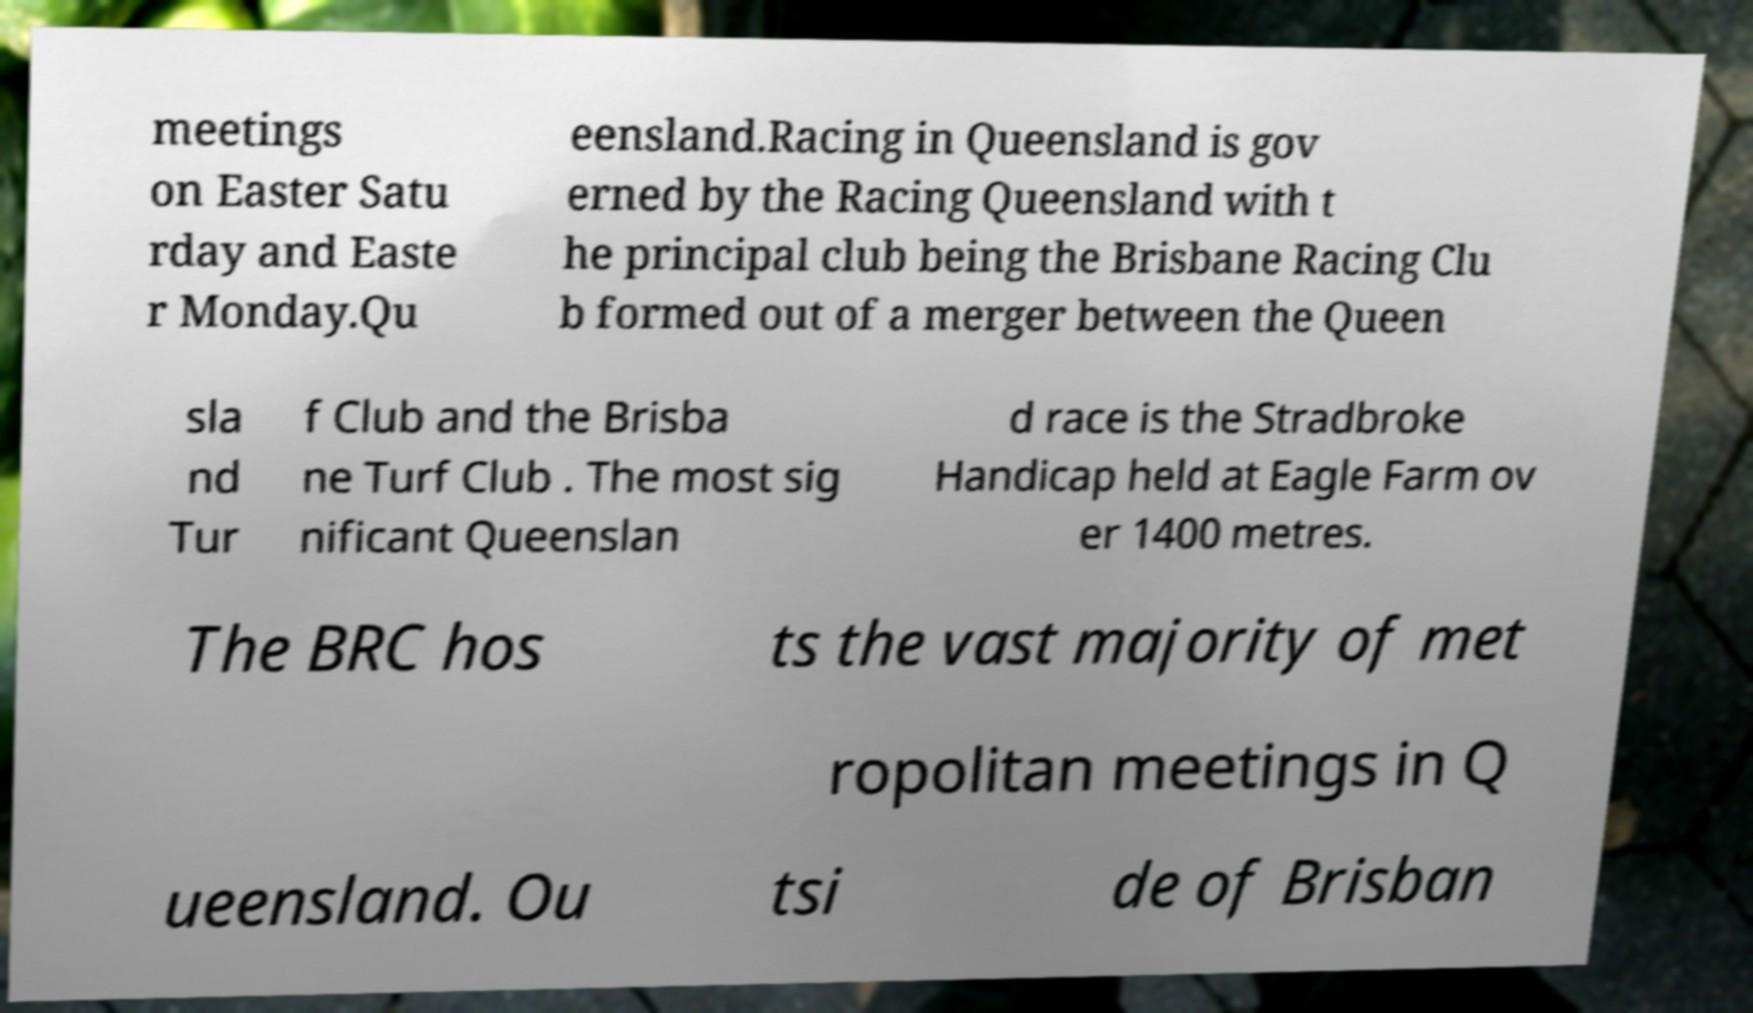Could you extract and type out the text from this image? meetings on Easter Satu rday and Easte r Monday.Qu eensland.Racing in Queensland is gov erned by the Racing Queensland with t he principal club being the Brisbane Racing Clu b formed out of a merger between the Queen sla nd Tur f Club and the Brisba ne Turf Club . The most sig nificant Queenslan d race is the Stradbroke Handicap held at Eagle Farm ov er 1400 metres. The BRC hos ts the vast majority of met ropolitan meetings in Q ueensland. Ou tsi de of Brisban 